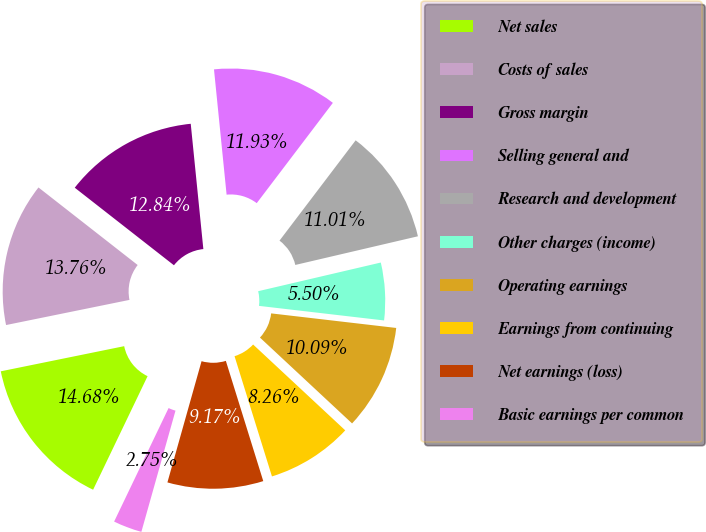Convert chart to OTSL. <chart><loc_0><loc_0><loc_500><loc_500><pie_chart><fcel>Net sales<fcel>Costs of sales<fcel>Gross margin<fcel>Selling general and<fcel>Research and development<fcel>Other charges (income)<fcel>Operating earnings<fcel>Earnings from continuing<fcel>Net earnings (loss)<fcel>Basic earnings per common<nl><fcel>14.68%<fcel>13.76%<fcel>12.84%<fcel>11.93%<fcel>11.01%<fcel>5.5%<fcel>10.09%<fcel>8.26%<fcel>9.17%<fcel>2.75%<nl></chart> 